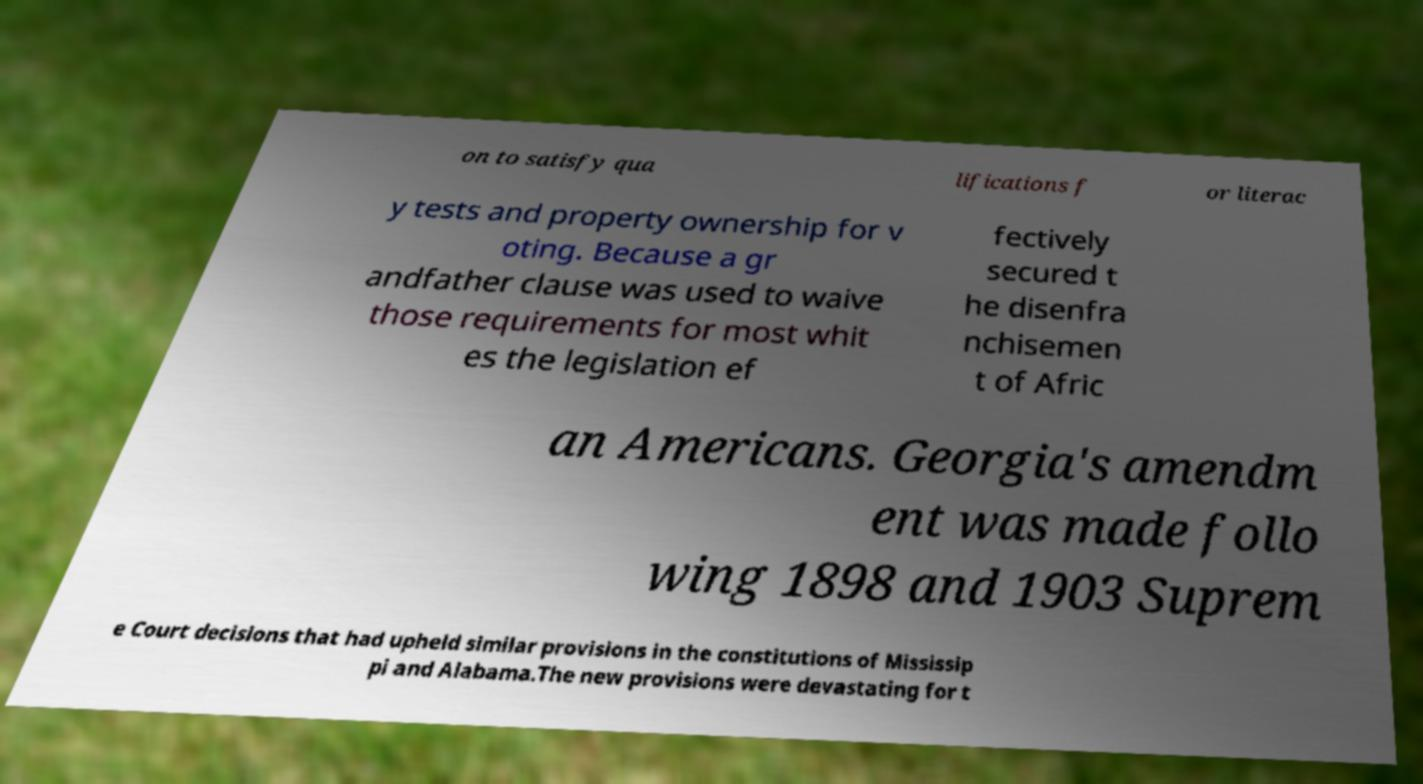There's text embedded in this image that I need extracted. Can you transcribe it verbatim? on to satisfy qua lifications f or literac y tests and property ownership for v oting. Because a gr andfather clause was used to waive those requirements for most whit es the legislation ef fectively secured t he disenfra nchisemen t of Afric an Americans. Georgia's amendm ent was made follo wing 1898 and 1903 Suprem e Court decisions that had upheld similar provisions in the constitutions of Mississip pi and Alabama.The new provisions were devastating for t 